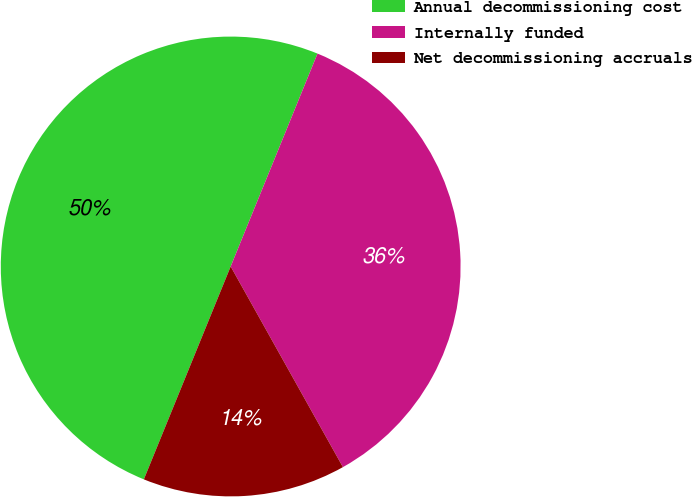Convert chart. <chart><loc_0><loc_0><loc_500><loc_500><pie_chart><fcel>Annual decommissioning cost<fcel>Internally funded<fcel>Net decommissioning accruals<nl><fcel>50.0%<fcel>35.72%<fcel>14.28%<nl></chart> 